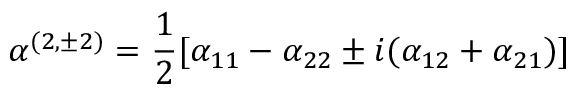Convert formula to latex. <formula><loc_0><loc_0><loc_500><loc_500>\alpha ^ { ( 2 , \pm 2 ) } = \frac { 1 } { 2 } [ \alpha _ { 1 1 } - \alpha _ { 2 2 } \pm i ( \alpha _ { 1 2 } + \alpha _ { 2 1 } ) ]</formula> 